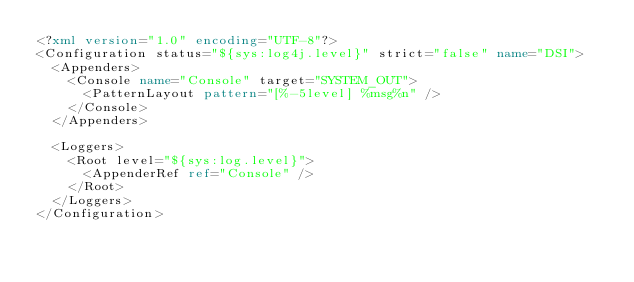<code> <loc_0><loc_0><loc_500><loc_500><_XML_><?xml version="1.0" encoding="UTF-8"?>
<Configuration status="${sys:log4j.level}" strict="false" name="DSI">
  <Appenders>
    <Console name="Console" target="SYSTEM_OUT">
      <PatternLayout pattern="[%-5level] %msg%n" />
    </Console>
  </Appenders>

  <Loggers>
    <Root level="${sys:log.level}">
      <AppenderRef ref="Console" />
    </Root>
  </Loggers>
</Configuration></code> 